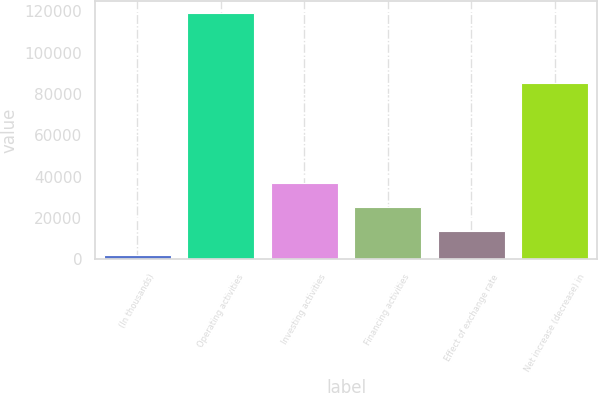Convert chart to OTSL. <chart><loc_0><loc_0><loc_500><loc_500><bar_chart><fcel>(In thousands)<fcel>Operating activities<fcel>Investing activities<fcel>Financing activities<fcel>Effect of exchange rate<fcel>Net increase (decrease) in<nl><fcel>2009<fcel>119041<fcel>37118.6<fcel>25415.4<fcel>13712.2<fcel>85255<nl></chart> 